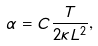<formula> <loc_0><loc_0><loc_500><loc_500>\alpha = C \frac { T } { 2 \kappa L ^ { 2 } } ,</formula> 